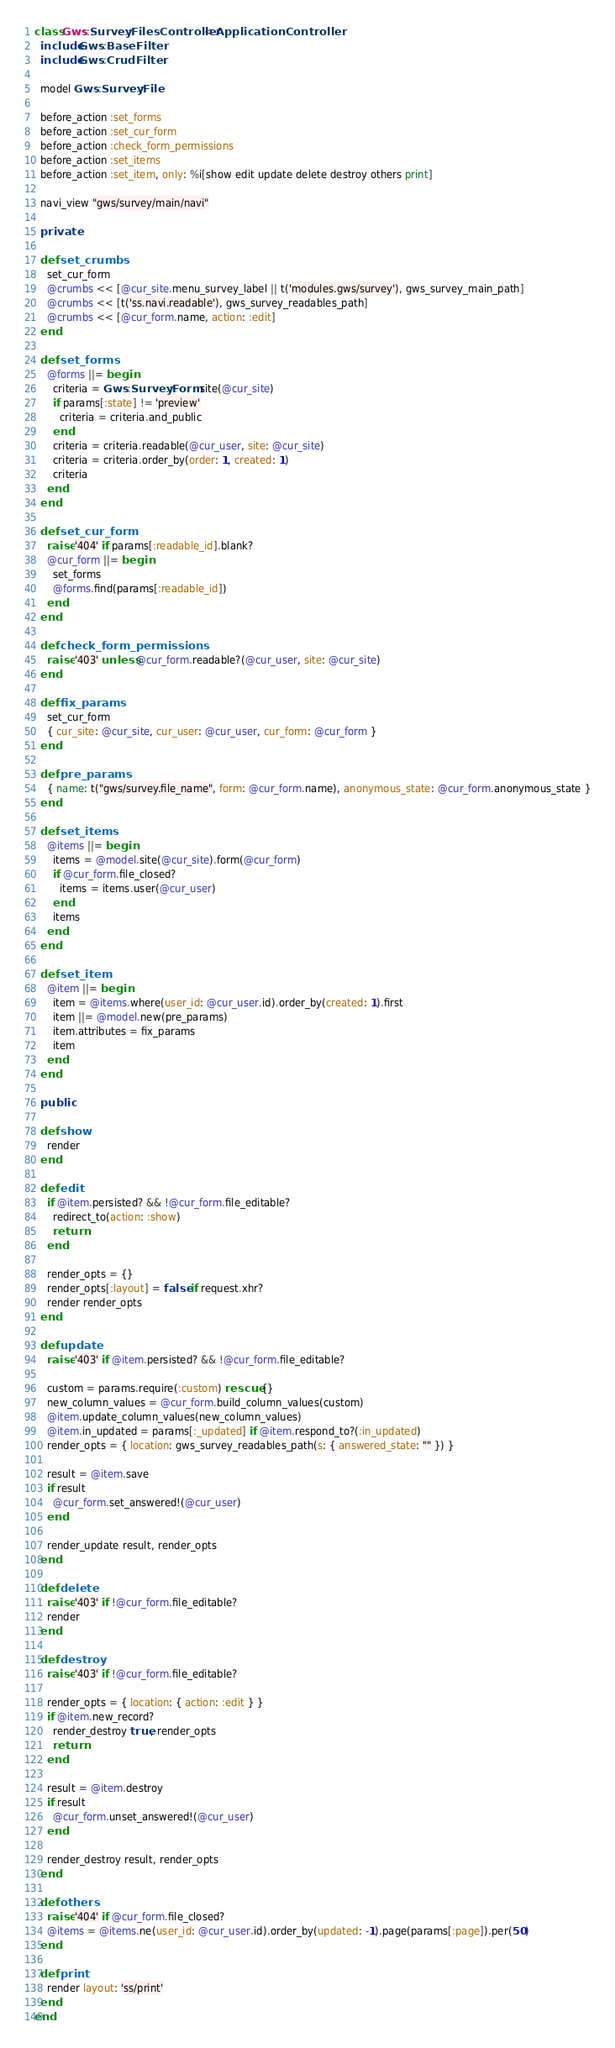Convert code to text. <code><loc_0><loc_0><loc_500><loc_500><_Ruby_>class Gws::Survey::FilesController < ApplicationController
  include Gws::BaseFilter
  include Gws::CrudFilter

  model Gws::Survey::File

  before_action :set_forms
  before_action :set_cur_form
  before_action :check_form_permissions
  before_action :set_items
  before_action :set_item, only: %i[show edit update delete destroy others print]

  navi_view "gws/survey/main/navi"

  private

  def set_crumbs
    set_cur_form
    @crumbs << [@cur_site.menu_survey_label || t('modules.gws/survey'), gws_survey_main_path]
    @crumbs << [t('ss.navi.readable'), gws_survey_readables_path]
    @crumbs << [@cur_form.name, action: :edit]
  end

  def set_forms
    @forms ||= begin
      criteria = Gws::Survey::Form.site(@cur_site)
      if params[:state] != 'preview'
        criteria = criteria.and_public
      end
      criteria = criteria.readable(@cur_user, site: @cur_site)
      criteria = criteria.order_by(order: 1, created: 1)
      criteria
    end
  end

  def set_cur_form
    raise '404' if params[:readable_id].blank?
    @cur_form ||= begin
      set_forms
      @forms.find(params[:readable_id])
    end
  end

  def check_form_permissions
    raise '403' unless @cur_form.readable?(@cur_user, site: @cur_site)
  end

  def fix_params
    set_cur_form
    { cur_site: @cur_site, cur_user: @cur_user, cur_form: @cur_form }
  end

  def pre_params
    { name: t("gws/survey.file_name", form: @cur_form.name), anonymous_state: @cur_form.anonymous_state }
  end

  def set_items
    @items ||= begin
      items = @model.site(@cur_site).form(@cur_form)
      if @cur_form.file_closed?
        items = items.user(@cur_user)
      end
      items
    end
  end

  def set_item
    @item ||= begin
      item = @items.where(user_id: @cur_user.id).order_by(created: 1).first
      item ||= @model.new(pre_params)
      item.attributes = fix_params
      item
    end
  end

  public

  def show
    render
  end

  def edit
    if @item.persisted? && !@cur_form.file_editable?
      redirect_to(action: :show)
      return
    end

    render_opts = {}
    render_opts[:layout] = false if request.xhr?
    render render_opts
  end

  def update
    raise '403' if @item.persisted? && !@cur_form.file_editable?

    custom = params.require(:custom) rescue {}
    new_column_values = @cur_form.build_column_values(custom)
    @item.update_column_values(new_column_values)
    @item.in_updated = params[:_updated] if @item.respond_to?(:in_updated)
    render_opts = { location: gws_survey_readables_path(s: { answered_state: "" }) }

    result = @item.save
    if result
      @cur_form.set_answered!(@cur_user)
    end

    render_update result, render_opts
  end

  def delete
    raise '403' if !@cur_form.file_editable?
    render
  end

  def destroy
    raise '403' if !@cur_form.file_editable?

    render_opts = { location: { action: :edit } }
    if @item.new_record?
      render_destroy true, render_opts
      return
    end

    result = @item.destroy
    if result
      @cur_form.unset_answered!(@cur_user)
    end

    render_destroy result, render_opts
  end

  def others
    raise '404' if @cur_form.file_closed?
    @items = @items.ne(user_id: @cur_user.id).order_by(updated: -1).page(params[:page]).per(50)
  end

  def print
    render layout: 'ss/print'
  end
end
</code> 